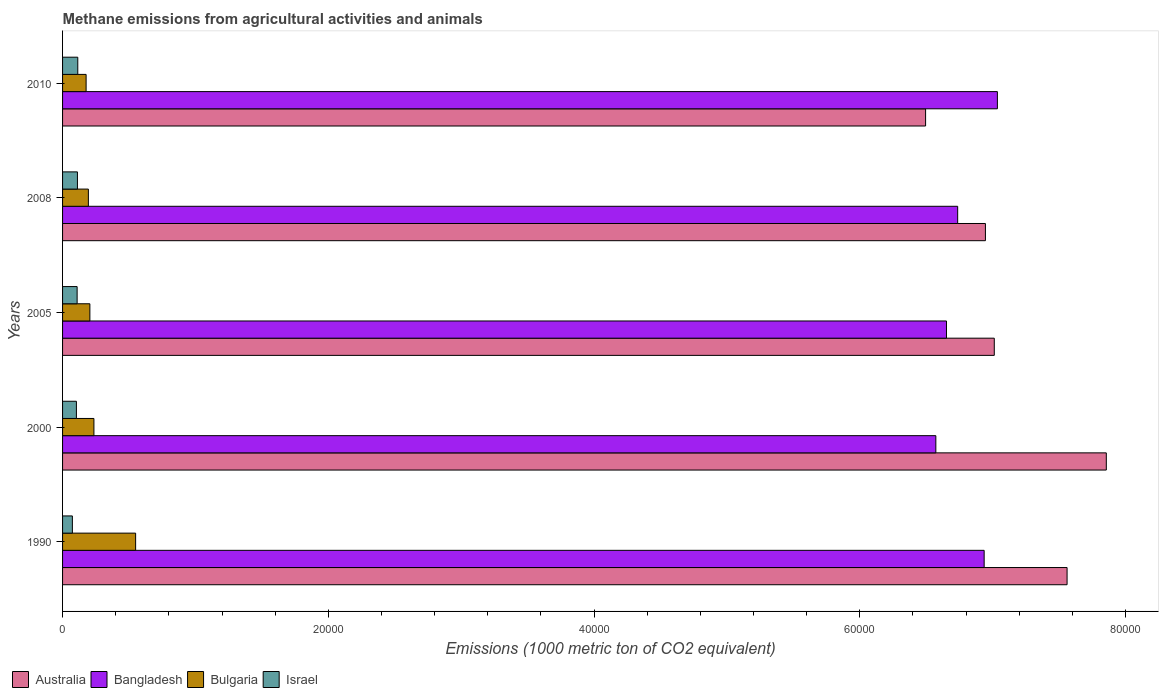Are the number of bars per tick equal to the number of legend labels?
Your answer should be compact. Yes. What is the label of the 3rd group of bars from the top?
Provide a succinct answer. 2005. What is the amount of methane emitted in Bangladesh in 1990?
Your answer should be very brief. 6.94e+04. Across all years, what is the maximum amount of methane emitted in Australia?
Provide a succinct answer. 7.85e+04. Across all years, what is the minimum amount of methane emitted in Israel?
Offer a terse response. 737.7. In which year was the amount of methane emitted in Australia maximum?
Give a very brief answer. 2000. What is the total amount of methane emitted in Bangladesh in the graph?
Offer a terse response. 3.39e+05. What is the difference between the amount of methane emitted in Australia in 1990 and that in 2008?
Keep it short and to the point. 6145.3. What is the difference between the amount of methane emitted in Bulgaria in 2005 and the amount of methane emitted in Australia in 2008?
Your response must be concise. -6.74e+04. What is the average amount of methane emitted in Bangladesh per year?
Offer a terse response. 6.79e+04. In the year 2000, what is the difference between the amount of methane emitted in Australia and amount of methane emitted in Bulgaria?
Offer a very short reply. 7.62e+04. In how many years, is the amount of methane emitted in Bulgaria greater than 72000 1000 metric ton?
Offer a terse response. 0. What is the ratio of the amount of methane emitted in Australia in 2005 to that in 2008?
Your answer should be very brief. 1.01. Is the amount of methane emitted in Israel in 1990 less than that in 2005?
Provide a short and direct response. Yes. What is the difference between the highest and the second highest amount of methane emitted in Bangladesh?
Your response must be concise. 996. What is the difference between the highest and the lowest amount of methane emitted in Israel?
Offer a very short reply. 407.8. In how many years, is the amount of methane emitted in Israel greater than the average amount of methane emitted in Israel taken over all years?
Your answer should be very brief. 4. Is the sum of the amount of methane emitted in Australia in 1990 and 2005 greater than the maximum amount of methane emitted in Israel across all years?
Give a very brief answer. Yes. Is it the case that in every year, the sum of the amount of methane emitted in Bangladesh and amount of methane emitted in Israel is greater than the sum of amount of methane emitted in Bulgaria and amount of methane emitted in Australia?
Your answer should be compact. Yes. What does the 4th bar from the bottom in 1990 represents?
Your response must be concise. Israel. Are all the bars in the graph horizontal?
Make the answer very short. Yes. How many years are there in the graph?
Provide a short and direct response. 5. Are the values on the major ticks of X-axis written in scientific E-notation?
Make the answer very short. No. Does the graph contain any zero values?
Your answer should be compact. No. Does the graph contain grids?
Give a very brief answer. No. What is the title of the graph?
Keep it short and to the point. Methane emissions from agricultural activities and animals. Does "Mauritania" appear as one of the legend labels in the graph?
Make the answer very short. No. What is the label or title of the X-axis?
Your response must be concise. Emissions (1000 metric ton of CO2 equivalent). What is the Emissions (1000 metric ton of CO2 equivalent) in Australia in 1990?
Ensure brevity in your answer.  7.56e+04. What is the Emissions (1000 metric ton of CO2 equivalent) in Bangladesh in 1990?
Offer a very short reply. 6.94e+04. What is the Emissions (1000 metric ton of CO2 equivalent) in Bulgaria in 1990?
Your answer should be compact. 5498.3. What is the Emissions (1000 metric ton of CO2 equivalent) of Israel in 1990?
Provide a short and direct response. 737.7. What is the Emissions (1000 metric ton of CO2 equivalent) in Australia in 2000?
Provide a short and direct response. 7.85e+04. What is the Emissions (1000 metric ton of CO2 equivalent) of Bangladesh in 2000?
Provide a short and direct response. 6.57e+04. What is the Emissions (1000 metric ton of CO2 equivalent) in Bulgaria in 2000?
Provide a short and direct response. 2359.5. What is the Emissions (1000 metric ton of CO2 equivalent) in Israel in 2000?
Ensure brevity in your answer.  1041.6. What is the Emissions (1000 metric ton of CO2 equivalent) of Australia in 2005?
Make the answer very short. 7.01e+04. What is the Emissions (1000 metric ton of CO2 equivalent) in Bangladesh in 2005?
Your answer should be compact. 6.65e+04. What is the Emissions (1000 metric ton of CO2 equivalent) in Bulgaria in 2005?
Ensure brevity in your answer.  2055.2. What is the Emissions (1000 metric ton of CO2 equivalent) in Israel in 2005?
Your answer should be very brief. 1095.9. What is the Emissions (1000 metric ton of CO2 equivalent) in Australia in 2008?
Your response must be concise. 6.95e+04. What is the Emissions (1000 metric ton of CO2 equivalent) in Bangladesh in 2008?
Offer a terse response. 6.74e+04. What is the Emissions (1000 metric ton of CO2 equivalent) in Bulgaria in 2008?
Your response must be concise. 1942.2. What is the Emissions (1000 metric ton of CO2 equivalent) of Israel in 2008?
Offer a very short reply. 1119.7. What is the Emissions (1000 metric ton of CO2 equivalent) in Australia in 2010?
Ensure brevity in your answer.  6.50e+04. What is the Emissions (1000 metric ton of CO2 equivalent) of Bangladesh in 2010?
Offer a very short reply. 7.04e+04. What is the Emissions (1000 metric ton of CO2 equivalent) in Bulgaria in 2010?
Your answer should be compact. 1771.6. What is the Emissions (1000 metric ton of CO2 equivalent) in Israel in 2010?
Ensure brevity in your answer.  1145.5. Across all years, what is the maximum Emissions (1000 metric ton of CO2 equivalent) of Australia?
Your answer should be compact. 7.85e+04. Across all years, what is the maximum Emissions (1000 metric ton of CO2 equivalent) of Bangladesh?
Offer a terse response. 7.04e+04. Across all years, what is the maximum Emissions (1000 metric ton of CO2 equivalent) of Bulgaria?
Give a very brief answer. 5498.3. Across all years, what is the maximum Emissions (1000 metric ton of CO2 equivalent) of Israel?
Your answer should be very brief. 1145.5. Across all years, what is the minimum Emissions (1000 metric ton of CO2 equivalent) in Australia?
Offer a terse response. 6.50e+04. Across all years, what is the minimum Emissions (1000 metric ton of CO2 equivalent) in Bangladesh?
Your response must be concise. 6.57e+04. Across all years, what is the minimum Emissions (1000 metric ton of CO2 equivalent) of Bulgaria?
Offer a terse response. 1771.6. Across all years, what is the minimum Emissions (1000 metric ton of CO2 equivalent) of Israel?
Provide a short and direct response. 737.7. What is the total Emissions (1000 metric ton of CO2 equivalent) in Australia in the graph?
Your answer should be compact. 3.59e+05. What is the total Emissions (1000 metric ton of CO2 equivalent) in Bangladesh in the graph?
Ensure brevity in your answer.  3.39e+05. What is the total Emissions (1000 metric ton of CO2 equivalent) in Bulgaria in the graph?
Offer a terse response. 1.36e+04. What is the total Emissions (1000 metric ton of CO2 equivalent) in Israel in the graph?
Offer a terse response. 5140.4. What is the difference between the Emissions (1000 metric ton of CO2 equivalent) of Australia in 1990 and that in 2000?
Offer a terse response. -2952.5. What is the difference between the Emissions (1000 metric ton of CO2 equivalent) in Bangladesh in 1990 and that in 2000?
Provide a short and direct response. 3636.5. What is the difference between the Emissions (1000 metric ton of CO2 equivalent) of Bulgaria in 1990 and that in 2000?
Give a very brief answer. 3138.8. What is the difference between the Emissions (1000 metric ton of CO2 equivalent) of Israel in 1990 and that in 2000?
Keep it short and to the point. -303.9. What is the difference between the Emissions (1000 metric ton of CO2 equivalent) in Australia in 1990 and that in 2005?
Your response must be concise. 5478.7. What is the difference between the Emissions (1000 metric ton of CO2 equivalent) of Bangladesh in 1990 and that in 2005?
Make the answer very short. 2835.6. What is the difference between the Emissions (1000 metric ton of CO2 equivalent) of Bulgaria in 1990 and that in 2005?
Provide a short and direct response. 3443.1. What is the difference between the Emissions (1000 metric ton of CO2 equivalent) in Israel in 1990 and that in 2005?
Provide a succinct answer. -358.2. What is the difference between the Emissions (1000 metric ton of CO2 equivalent) of Australia in 1990 and that in 2008?
Ensure brevity in your answer.  6145.3. What is the difference between the Emissions (1000 metric ton of CO2 equivalent) of Bangladesh in 1990 and that in 2008?
Ensure brevity in your answer.  1993. What is the difference between the Emissions (1000 metric ton of CO2 equivalent) of Bulgaria in 1990 and that in 2008?
Make the answer very short. 3556.1. What is the difference between the Emissions (1000 metric ton of CO2 equivalent) of Israel in 1990 and that in 2008?
Provide a short and direct response. -382. What is the difference between the Emissions (1000 metric ton of CO2 equivalent) of Australia in 1990 and that in 2010?
Your answer should be compact. 1.06e+04. What is the difference between the Emissions (1000 metric ton of CO2 equivalent) in Bangladesh in 1990 and that in 2010?
Your answer should be very brief. -996. What is the difference between the Emissions (1000 metric ton of CO2 equivalent) in Bulgaria in 1990 and that in 2010?
Your answer should be very brief. 3726.7. What is the difference between the Emissions (1000 metric ton of CO2 equivalent) of Israel in 1990 and that in 2010?
Offer a terse response. -407.8. What is the difference between the Emissions (1000 metric ton of CO2 equivalent) of Australia in 2000 and that in 2005?
Give a very brief answer. 8431.2. What is the difference between the Emissions (1000 metric ton of CO2 equivalent) of Bangladesh in 2000 and that in 2005?
Ensure brevity in your answer.  -800.9. What is the difference between the Emissions (1000 metric ton of CO2 equivalent) of Bulgaria in 2000 and that in 2005?
Your answer should be very brief. 304.3. What is the difference between the Emissions (1000 metric ton of CO2 equivalent) of Israel in 2000 and that in 2005?
Offer a terse response. -54.3. What is the difference between the Emissions (1000 metric ton of CO2 equivalent) of Australia in 2000 and that in 2008?
Keep it short and to the point. 9097.8. What is the difference between the Emissions (1000 metric ton of CO2 equivalent) in Bangladesh in 2000 and that in 2008?
Provide a short and direct response. -1643.5. What is the difference between the Emissions (1000 metric ton of CO2 equivalent) of Bulgaria in 2000 and that in 2008?
Make the answer very short. 417.3. What is the difference between the Emissions (1000 metric ton of CO2 equivalent) in Israel in 2000 and that in 2008?
Provide a short and direct response. -78.1. What is the difference between the Emissions (1000 metric ton of CO2 equivalent) in Australia in 2000 and that in 2010?
Offer a terse response. 1.36e+04. What is the difference between the Emissions (1000 metric ton of CO2 equivalent) of Bangladesh in 2000 and that in 2010?
Keep it short and to the point. -4632.5. What is the difference between the Emissions (1000 metric ton of CO2 equivalent) of Bulgaria in 2000 and that in 2010?
Offer a terse response. 587.9. What is the difference between the Emissions (1000 metric ton of CO2 equivalent) of Israel in 2000 and that in 2010?
Provide a short and direct response. -103.9. What is the difference between the Emissions (1000 metric ton of CO2 equivalent) of Australia in 2005 and that in 2008?
Give a very brief answer. 666.6. What is the difference between the Emissions (1000 metric ton of CO2 equivalent) of Bangladesh in 2005 and that in 2008?
Give a very brief answer. -842.6. What is the difference between the Emissions (1000 metric ton of CO2 equivalent) of Bulgaria in 2005 and that in 2008?
Offer a very short reply. 113. What is the difference between the Emissions (1000 metric ton of CO2 equivalent) of Israel in 2005 and that in 2008?
Offer a terse response. -23.8. What is the difference between the Emissions (1000 metric ton of CO2 equivalent) of Australia in 2005 and that in 2010?
Provide a short and direct response. 5168.4. What is the difference between the Emissions (1000 metric ton of CO2 equivalent) in Bangladesh in 2005 and that in 2010?
Provide a succinct answer. -3831.6. What is the difference between the Emissions (1000 metric ton of CO2 equivalent) of Bulgaria in 2005 and that in 2010?
Provide a succinct answer. 283.6. What is the difference between the Emissions (1000 metric ton of CO2 equivalent) of Israel in 2005 and that in 2010?
Provide a short and direct response. -49.6. What is the difference between the Emissions (1000 metric ton of CO2 equivalent) in Australia in 2008 and that in 2010?
Give a very brief answer. 4501.8. What is the difference between the Emissions (1000 metric ton of CO2 equivalent) of Bangladesh in 2008 and that in 2010?
Make the answer very short. -2989. What is the difference between the Emissions (1000 metric ton of CO2 equivalent) of Bulgaria in 2008 and that in 2010?
Provide a short and direct response. 170.6. What is the difference between the Emissions (1000 metric ton of CO2 equivalent) in Israel in 2008 and that in 2010?
Provide a short and direct response. -25.8. What is the difference between the Emissions (1000 metric ton of CO2 equivalent) in Australia in 1990 and the Emissions (1000 metric ton of CO2 equivalent) in Bangladesh in 2000?
Keep it short and to the point. 9876.4. What is the difference between the Emissions (1000 metric ton of CO2 equivalent) of Australia in 1990 and the Emissions (1000 metric ton of CO2 equivalent) of Bulgaria in 2000?
Offer a very short reply. 7.32e+04. What is the difference between the Emissions (1000 metric ton of CO2 equivalent) in Australia in 1990 and the Emissions (1000 metric ton of CO2 equivalent) in Israel in 2000?
Ensure brevity in your answer.  7.46e+04. What is the difference between the Emissions (1000 metric ton of CO2 equivalent) in Bangladesh in 1990 and the Emissions (1000 metric ton of CO2 equivalent) in Bulgaria in 2000?
Make the answer very short. 6.70e+04. What is the difference between the Emissions (1000 metric ton of CO2 equivalent) in Bangladesh in 1990 and the Emissions (1000 metric ton of CO2 equivalent) in Israel in 2000?
Give a very brief answer. 6.83e+04. What is the difference between the Emissions (1000 metric ton of CO2 equivalent) of Bulgaria in 1990 and the Emissions (1000 metric ton of CO2 equivalent) of Israel in 2000?
Your answer should be compact. 4456.7. What is the difference between the Emissions (1000 metric ton of CO2 equivalent) of Australia in 1990 and the Emissions (1000 metric ton of CO2 equivalent) of Bangladesh in 2005?
Your response must be concise. 9075.5. What is the difference between the Emissions (1000 metric ton of CO2 equivalent) of Australia in 1990 and the Emissions (1000 metric ton of CO2 equivalent) of Bulgaria in 2005?
Your answer should be very brief. 7.35e+04. What is the difference between the Emissions (1000 metric ton of CO2 equivalent) in Australia in 1990 and the Emissions (1000 metric ton of CO2 equivalent) in Israel in 2005?
Keep it short and to the point. 7.45e+04. What is the difference between the Emissions (1000 metric ton of CO2 equivalent) in Bangladesh in 1990 and the Emissions (1000 metric ton of CO2 equivalent) in Bulgaria in 2005?
Offer a very short reply. 6.73e+04. What is the difference between the Emissions (1000 metric ton of CO2 equivalent) of Bangladesh in 1990 and the Emissions (1000 metric ton of CO2 equivalent) of Israel in 2005?
Your answer should be compact. 6.83e+04. What is the difference between the Emissions (1000 metric ton of CO2 equivalent) of Bulgaria in 1990 and the Emissions (1000 metric ton of CO2 equivalent) of Israel in 2005?
Offer a very short reply. 4402.4. What is the difference between the Emissions (1000 metric ton of CO2 equivalent) of Australia in 1990 and the Emissions (1000 metric ton of CO2 equivalent) of Bangladesh in 2008?
Keep it short and to the point. 8232.9. What is the difference between the Emissions (1000 metric ton of CO2 equivalent) in Australia in 1990 and the Emissions (1000 metric ton of CO2 equivalent) in Bulgaria in 2008?
Offer a terse response. 7.37e+04. What is the difference between the Emissions (1000 metric ton of CO2 equivalent) of Australia in 1990 and the Emissions (1000 metric ton of CO2 equivalent) of Israel in 2008?
Offer a very short reply. 7.45e+04. What is the difference between the Emissions (1000 metric ton of CO2 equivalent) in Bangladesh in 1990 and the Emissions (1000 metric ton of CO2 equivalent) in Bulgaria in 2008?
Make the answer very short. 6.74e+04. What is the difference between the Emissions (1000 metric ton of CO2 equivalent) in Bangladesh in 1990 and the Emissions (1000 metric ton of CO2 equivalent) in Israel in 2008?
Make the answer very short. 6.82e+04. What is the difference between the Emissions (1000 metric ton of CO2 equivalent) of Bulgaria in 1990 and the Emissions (1000 metric ton of CO2 equivalent) of Israel in 2008?
Offer a very short reply. 4378.6. What is the difference between the Emissions (1000 metric ton of CO2 equivalent) in Australia in 1990 and the Emissions (1000 metric ton of CO2 equivalent) in Bangladesh in 2010?
Your answer should be very brief. 5243.9. What is the difference between the Emissions (1000 metric ton of CO2 equivalent) of Australia in 1990 and the Emissions (1000 metric ton of CO2 equivalent) of Bulgaria in 2010?
Provide a short and direct response. 7.38e+04. What is the difference between the Emissions (1000 metric ton of CO2 equivalent) in Australia in 1990 and the Emissions (1000 metric ton of CO2 equivalent) in Israel in 2010?
Your answer should be very brief. 7.45e+04. What is the difference between the Emissions (1000 metric ton of CO2 equivalent) in Bangladesh in 1990 and the Emissions (1000 metric ton of CO2 equivalent) in Bulgaria in 2010?
Your response must be concise. 6.76e+04. What is the difference between the Emissions (1000 metric ton of CO2 equivalent) in Bangladesh in 1990 and the Emissions (1000 metric ton of CO2 equivalent) in Israel in 2010?
Give a very brief answer. 6.82e+04. What is the difference between the Emissions (1000 metric ton of CO2 equivalent) of Bulgaria in 1990 and the Emissions (1000 metric ton of CO2 equivalent) of Israel in 2010?
Offer a very short reply. 4352.8. What is the difference between the Emissions (1000 metric ton of CO2 equivalent) of Australia in 2000 and the Emissions (1000 metric ton of CO2 equivalent) of Bangladesh in 2005?
Provide a short and direct response. 1.20e+04. What is the difference between the Emissions (1000 metric ton of CO2 equivalent) in Australia in 2000 and the Emissions (1000 metric ton of CO2 equivalent) in Bulgaria in 2005?
Your answer should be very brief. 7.65e+04. What is the difference between the Emissions (1000 metric ton of CO2 equivalent) of Australia in 2000 and the Emissions (1000 metric ton of CO2 equivalent) of Israel in 2005?
Provide a succinct answer. 7.75e+04. What is the difference between the Emissions (1000 metric ton of CO2 equivalent) in Bangladesh in 2000 and the Emissions (1000 metric ton of CO2 equivalent) in Bulgaria in 2005?
Offer a terse response. 6.37e+04. What is the difference between the Emissions (1000 metric ton of CO2 equivalent) in Bangladesh in 2000 and the Emissions (1000 metric ton of CO2 equivalent) in Israel in 2005?
Ensure brevity in your answer.  6.46e+04. What is the difference between the Emissions (1000 metric ton of CO2 equivalent) of Bulgaria in 2000 and the Emissions (1000 metric ton of CO2 equivalent) of Israel in 2005?
Keep it short and to the point. 1263.6. What is the difference between the Emissions (1000 metric ton of CO2 equivalent) in Australia in 2000 and the Emissions (1000 metric ton of CO2 equivalent) in Bangladesh in 2008?
Keep it short and to the point. 1.12e+04. What is the difference between the Emissions (1000 metric ton of CO2 equivalent) in Australia in 2000 and the Emissions (1000 metric ton of CO2 equivalent) in Bulgaria in 2008?
Ensure brevity in your answer.  7.66e+04. What is the difference between the Emissions (1000 metric ton of CO2 equivalent) in Australia in 2000 and the Emissions (1000 metric ton of CO2 equivalent) in Israel in 2008?
Make the answer very short. 7.74e+04. What is the difference between the Emissions (1000 metric ton of CO2 equivalent) in Bangladesh in 2000 and the Emissions (1000 metric ton of CO2 equivalent) in Bulgaria in 2008?
Ensure brevity in your answer.  6.38e+04. What is the difference between the Emissions (1000 metric ton of CO2 equivalent) of Bangladesh in 2000 and the Emissions (1000 metric ton of CO2 equivalent) of Israel in 2008?
Provide a short and direct response. 6.46e+04. What is the difference between the Emissions (1000 metric ton of CO2 equivalent) in Bulgaria in 2000 and the Emissions (1000 metric ton of CO2 equivalent) in Israel in 2008?
Offer a terse response. 1239.8. What is the difference between the Emissions (1000 metric ton of CO2 equivalent) of Australia in 2000 and the Emissions (1000 metric ton of CO2 equivalent) of Bangladesh in 2010?
Your answer should be compact. 8196.4. What is the difference between the Emissions (1000 metric ton of CO2 equivalent) of Australia in 2000 and the Emissions (1000 metric ton of CO2 equivalent) of Bulgaria in 2010?
Ensure brevity in your answer.  7.68e+04. What is the difference between the Emissions (1000 metric ton of CO2 equivalent) of Australia in 2000 and the Emissions (1000 metric ton of CO2 equivalent) of Israel in 2010?
Provide a short and direct response. 7.74e+04. What is the difference between the Emissions (1000 metric ton of CO2 equivalent) of Bangladesh in 2000 and the Emissions (1000 metric ton of CO2 equivalent) of Bulgaria in 2010?
Make the answer very short. 6.39e+04. What is the difference between the Emissions (1000 metric ton of CO2 equivalent) in Bangladesh in 2000 and the Emissions (1000 metric ton of CO2 equivalent) in Israel in 2010?
Keep it short and to the point. 6.46e+04. What is the difference between the Emissions (1000 metric ton of CO2 equivalent) of Bulgaria in 2000 and the Emissions (1000 metric ton of CO2 equivalent) of Israel in 2010?
Offer a very short reply. 1214. What is the difference between the Emissions (1000 metric ton of CO2 equivalent) of Australia in 2005 and the Emissions (1000 metric ton of CO2 equivalent) of Bangladesh in 2008?
Your answer should be compact. 2754.2. What is the difference between the Emissions (1000 metric ton of CO2 equivalent) of Australia in 2005 and the Emissions (1000 metric ton of CO2 equivalent) of Bulgaria in 2008?
Provide a succinct answer. 6.82e+04. What is the difference between the Emissions (1000 metric ton of CO2 equivalent) of Australia in 2005 and the Emissions (1000 metric ton of CO2 equivalent) of Israel in 2008?
Make the answer very short. 6.90e+04. What is the difference between the Emissions (1000 metric ton of CO2 equivalent) in Bangladesh in 2005 and the Emissions (1000 metric ton of CO2 equivalent) in Bulgaria in 2008?
Offer a very short reply. 6.46e+04. What is the difference between the Emissions (1000 metric ton of CO2 equivalent) in Bangladesh in 2005 and the Emissions (1000 metric ton of CO2 equivalent) in Israel in 2008?
Your answer should be very brief. 6.54e+04. What is the difference between the Emissions (1000 metric ton of CO2 equivalent) in Bulgaria in 2005 and the Emissions (1000 metric ton of CO2 equivalent) in Israel in 2008?
Your response must be concise. 935.5. What is the difference between the Emissions (1000 metric ton of CO2 equivalent) of Australia in 2005 and the Emissions (1000 metric ton of CO2 equivalent) of Bangladesh in 2010?
Make the answer very short. -234.8. What is the difference between the Emissions (1000 metric ton of CO2 equivalent) of Australia in 2005 and the Emissions (1000 metric ton of CO2 equivalent) of Bulgaria in 2010?
Provide a succinct answer. 6.83e+04. What is the difference between the Emissions (1000 metric ton of CO2 equivalent) of Australia in 2005 and the Emissions (1000 metric ton of CO2 equivalent) of Israel in 2010?
Ensure brevity in your answer.  6.90e+04. What is the difference between the Emissions (1000 metric ton of CO2 equivalent) in Bangladesh in 2005 and the Emissions (1000 metric ton of CO2 equivalent) in Bulgaria in 2010?
Provide a short and direct response. 6.48e+04. What is the difference between the Emissions (1000 metric ton of CO2 equivalent) in Bangladesh in 2005 and the Emissions (1000 metric ton of CO2 equivalent) in Israel in 2010?
Provide a short and direct response. 6.54e+04. What is the difference between the Emissions (1000 metric ton of CO2 equivalent) in Bulgaria in 2005 and the Emissions (1000 metric ton of CO2 equivalent) in Israel in 2010?
Give a very brief answer. 909.7. What is the difference between the Emissions (1000 metric ton of CO2 equivalent) of Australia in 2008 and the Emissions (1000 metric ton of CO2 equivalent) of Bangladesh in 2010?
Provide a succinct answer. -901.4. What is the difference between the Emissions (1000 metric ton of CO2 equivalent) of Australia in 2008 and the Emissions (1000 metric ton of CO2 equivalent) of Bulgaria in 2010?
Your response must be concise. 6.77e+04. What is the difference between the Emissions (1000 metric ton of CO2 equivalent) of Australia in 2008 and the Emissions (1000 metric ton of CO2 equivalent) of Israel in 2010?
Your answer should be compact. 6.83e+04. What is the difference between the Emissions (1000 metric ton of CO2 equivalent) of Bangladesh in 2008 and the Emissions (1000 metric ton of CO2 equivalent) of Bulgaria in 2010?
Your answer should be very brief. 6.56e+04. What is the difference between the Emissions (1000 metric ton of CO2 equivalent) in Bangladesh in 2008 and the Emissions (1000 metric ton of CO2 equivalent) in Israel in 2010?
Your answer should be very brief. 6.62e+04. What is the difference between the Emissions (1000 metric ton of CO2 equivalent) of Bulgaria in 2008 and the Emissions (1000 metric ton of CO2 equivalent) of Israel in 2010?
Your answer should be very brief. 796.7. What is the average Emissions (1000 metric ton of CO2 equivalent) in Australia per year?
Provide a succinct answer. 7.17e+04. What is the average Emissions (1000 metric ton of CO2 equivalent) in Bangladesh per year?
Make the answer very short. 6.79e+04. What is the average Emissions (1000 metric ton of CO2 equivalent) of Bulgaria per year?
Give a very brief answer. 2725.36. What is the average Emissions (1000 metric ton of CO2 equivalent) in Israel per year?
Your response must be concise. 1028.08. In the year 1990, what is the difference between the Emissions (1000 metric ton of CO2 equivalent) of Australia and Emissions (1000 metric ton of CO2 equivalent) of Bangladesh?
Provide a succinct answer. 6239.9. In the year 1990, what is the difference between the Emissions (1000 metric ton of CO2 equivalent) in Australia and Emissions (1000 metric ton of CO2 equivalent) in Bulgaria?
Provide a short and direct response. 7.01e+04. In the year 1990, what is the difference between the Emissions (1000 metric ton of CO2 equivalent) in Australia and Emissions (1000 metric ton of CO2 equivalent) in Israel?
Give a very brief answer. 7.49e+04. In the year 1990, what is the difference between the Emissions (1000 metric ton of CO2 equivalent) in Bangladesh and Emissions (1000 metric ton of CO2 equivalent) in Bulgaria?
Give a very brief answer. 6.39e+04. In the year 1990, what is the difference between the Emissions (1000 metric ton of CO2 equivalent) of Bangladesh and Emissions (1000 metric ton of CO2 equivalent) of Israel?
Make the answer very short. 6.86e+04. In the year 1990, what is the difference between the Emissions (1000 metric ton of CO2 equivalent) in Bulgaria and Emissions (1000 metric ton of CO2 equivalent) in Israel?
Provide a short and direct response. 4760.6. In the year 2000, what is the difference between the Emissions (1000 metric ton of CO2 equivalent) in Australia and Emissions (1000 metric ton of CO2 equivalent) in Bangladesh?
Ensure brevity in your answer.  1.28e+04. In the year 2000, what is the difference between the Emissions (1000 metric ton of CO2 equivalent) of Australia and Emissions (1000 metric ton of CO2 equivalent) of Bulgaria?
Make the answer very short. 7.62e+04. In the year 2000, what is the difference between the Emissions (1000 metric ton of CO2 equivalent) in Australia and Emissions (1000 metric ton of CO2 equivalent) in Israel?
Ensure brevity in your answer.  7.75e+04. In the year 2000, what is the difference between the Emissions (1000 metric ton of CO2 equivalent) of Bangladesh and Emissions (1000 metric ton of CO2 equivalent) of Bulgaria?
Offer a terse response. 6.34e+04. In the year 2000, what is the difference between the Emissions (1000 metric ton of CO2 equivalent) in Bangladesh and Emissions (1000 metric ton of CO2 equivalent) in Israel?
Keep it short and to the point. 6.47e+04. In the year 2000, what is the difference between the Emissions (1000 metric ton of CO2 equivalent) of Bulgaria and Emissions (1000 metric ton of CO2 equivalent) of Israel?
Keep it short and to the point. 1317.9. In the year 2005, what is the difference between the Emissions (1000 metric ton of CO2 equivalent) in Australia and Emissions (1000 metric ton of CO2 equivalent) in Bangladesh?
Make the answer very short. 3596.8. In the year 2005, what is the difference between the Emissions (1000 metric ton of CO2 equivalent) of Australia and Emissions (1000 metric ton of CO2 equivalent) of Bulgaria?
Keep it short and to the point. 6.81e+04. In the year 2005, what is the difference between the Emissions (1000 metric ton of CO2 equivalent) of Australia and Emissions (1000 metric ton of CO2 equivalent) of Israel?
Your answer should be very brief. 6.90e+04. In the year 2005, what is the difference between the Emissions (1000 metric ton of CO2 equivalent) of Bangladesh and Emissions (1000 metric ton of CO2 equivalent) of Bulgaria?
Provide a succinct answer. 6.45e+04. In the year 2005, what is the difference between the Emissions (1000 metric ton of CO2 equivalent) of Bangladesh and Emissions (1000 metric ton of CO2 equivalent) of Israel?
Give a very brief answer. 6.54e+04. In the year 2005, what is the difference between the Emissions (1000 metric ton of CO2 equivalent) of Bulgaria and Emissions (1000 metric ton of CO2 equivalent) of Israel?
Make the answer very short. 959.3. In the year 2008, what is the difference between the Emissions (1000 metric ton of CO2 equivalent) in Australia and Emissions (1000 metric ton of CO2 equivalent) in Bangladesh?
Keep it short and to the point. 2087.6. In the year 2008, what is the difference between the Emissions (1000 metric ton of CO2 equivalent) of Australia and Emissions (1000 metric ton of CO2 equivalent) of Bulgaria?
Give a very brief answer. 6.75e+04. In the year 2008, what is the difference between the Emissions (1000 metric ton of CO2 equivalent) of Australia and Emissions (1000 metric ton of CO2 equivalent) of Israel?
Offer a terse response. 6.83e+04. In the year 2008, what is the difference between the Emissions (1000 metric ton of CO2 equivalent) in Bangladesh and Emissions (1000 metric ton of CO2 equivalent) in Bulgaria?
Give a very brief answer. 6.54e+04. In the year 2008, what is the difference between the Emissions (1000 metric ton of CO2 equivalent) in Bangladesh and Emissions (1000 metric ton of CO2 equivalent) in Israel?
Offer a very short reply. 6.62e+04. In the year 2008, what is the difference between the Emissions (1000 metric ton of CO2 equivalent) of Bulgaria and Emissions (1000 metric ton of CO2 equivalent) of Israel?
Give a very brief answer. 822.5. In the year 2010, what is the difference between the Emissions (1000 metric ton of CO2 equivalent) of Australia and Emissions (1000 metric ton of CO2 equivalent) of Bangladesh?
Give a very brief answer. -5403.2. In the year 2010, what is the difference between the Emissions (1000 metric ton of CO2 equivalent) in Australia and Emissions (1000 metric ton of CO2 equivalent) in Bulgaria?
Provide a short and direct response. 6.32e+04. In the year 2010, what is the difference between the Emissions (1000 metric ton of CO2 equivalent) in Australia and Emissions (1000 metric ton of CO2 equivalent) in Israel?
Offer a terse response. 6.38e+04. In the year 2010, what is the difference between the Emissions (1000 metric ton of CO2 equivalent) in Bangladesh and Emissions (1000 metric ton of CO2 equivalent) in Bulgaria?
Provide a succinct answer. 6.86e+04. In the year 2010, what is the difference between the Emissions (1000 metric ton of CO2 equivalent) of Bangladesh and Emissions (1000 metric ton of CO2 equivalent) of Israel?
Your answer should be very brief. 6.92e+04. In the year 2010, what is the difference between the Emissions (1000 metric ton of CO2 equivalent) of Bulgaria and Emissions (1000 metric ton of CO2 equivalent) of Israel?
Give a very brief answer. 626.1. What is the ratio of the Emissions (1000 metric ton of CO2 equivalent) of Australia in 1990 to that in 2000?
Offer a terse response. 0.96. What is the ratio of the Emissions (1000 metric ton of CO2 equivalent) of Bangladesh in 1990 to that in 2000?
Your answer should be compact. 1.06. What is the ratio of the Emissions (1000 metric ton of CO2 equivalent) in Bulgaria in 1990 to that in 2000?
Ensure brevity in your answer.  2.33. What is the ratio of the Emissions (1000 metric ton of CO2 equivalent) of Israel in 1990 to that in 2000?
Your answer should be compact. 0.71. What is the ratio of the Emissions (1000 metric ton of CO2 equivalent) in Australia in 1990 to that in 2005?
Your response must be concise. 1.08. What is the ratio of the Emissions (1000 metric ton of CO2 equivalent) in Bangladesh in 1990 to that in 2005?
Give a very brief answer. 1.04. What is the ratio of the Emissions (1000 metric ton of CO2 equivalent) of Bulgaria in 1990 to that in 2005?
Offer a terse response. 2.68. What is the ratio of the Emissions (1000 metric ton of CO2 equivalent) of Israel in 1990 to that in 2005?
Offer a very short reply. 0.67. What is the ratio of the Emissions (1000 metric ton of CO2 equivalent) in Australia in 1990 to that in 2008?
Provide a succinct answer. 1.09. What is the ratio of the Emissions (1000 metric ton of CO2 equivalent) in Bangladesh in 1990 to that in 2008?
Give a very brief answer. 1.03. What is the ratio of the Emissions (1000 metric ton of CO2 equivalent) of Bulgaria in 1990 to that in 2008?
Provide a succinct answer. 2.83. What is the ratio of the Emissions (1000 metric ton of CO2 equivalent) in Israel in 1990 to that in 2008?
Your response must be concise. 0.66. What is the ratio of the Emissions (1000 metric ton of CO2 equivalent) of Australia in 1990 to that in 2010?
Offer a very short reply. 1.16. What is the ratio of the Emissions (1000 metric ton of CO2 equivalent) of Bangladesh in 1990 to that in 2010?
Ensure brevity in your answer.  0.99. What is the ratio of the Emissions (1000 metric ton of CO2 equivalent) in Bulgaria in 1990 to that in 2010?
Ensure brevity in your answer.  3.1. What is the ratio of the Emissions (1000 metric ton of CO2 equivalent) of Israel in 1990 to that in 2010?
Offer a terse response. 0.64. What is the ratio of the Emissions (1000 metric ton of CO2 equivalent) in Australia in 2000 to that in 2005?
Keep it short and to the point. 1.12. What is the ratio of the Emissions (1000 metric ton of CO2 equivalent) in Bulgaria in 2000 to that in 2005?
Provide a succinct answer. 1.15. What is the ratio of the Emissions (1000 metric ton of CO2 equivalent) in Israel in 2000 to that in 2005?
Make the answer very short. 0.95. What is the ratio of the Emissions (1000 metric ton of CO2 equivalent) in Australia in 2000 to that in 2008?
Your response must be concise. 1.13. What is the ratio of the Emissions (1000 metric ton of CO2 equivalent) of Bangladesh in 2000 to that in 2008?
Provide a succinct answer. 0.98. What is the ratio of the Emissions (1000 metric ton of CO2 equivalent) in Bulgaria in 2000 to that in 2008?
Offer a terse response. 1.21. What is the ratio of the Emissions (1000 metric ton of CO2 equivalent) of Israel in 2000 to that in 2008?
Give a very brief answer. 0.93. What is the ratio of the Emissions (1000 metric ton of CO2 equivalent) of Australia in 2000 to that in 2010?
Keep it short and to the point. 1.21. What is the ratio of the Emissions (1000 metric ton of CO2 equivalent) of Bangladesh in 2000 to that in 2010?
Offer a very short reply. 0.93. What is the ratio of the Emissions (1000 metric ton of CO2 equivalent) of Bulgaria in 2000 to that in 2010?
Provide a short and direct response. 1.33. What is the ratio of the Emissions (1000 metric ton of CO2 equivalent) of Israel in 2000 to that in 2010?
Provide a short and direct response. 0.91. What is the ratio of the Emissions (1000 metric ton of CO2 equivalent) of Australia in 2005 to that in 2008?
Offer a very short reply. 1.01. What is the ratio of the Emissions (1000 metric ton of CO2 equivalent) of Bangladesh in 2005 to that in 2008?
Provide a succinct answer. 0.99. What is the ratio of the Emissions (1000 metric ton of CO2 equivalent) in Bulgaria in 2005 to that in 2008?
Keep it short and to the point. 1.06. What is the ratio of the Emissions (1000 metric ton of CO2 equivalent) of Israel in 2005 to that in 2008?
Keep it short and to the point. 0.98. What is the ratio of the Emissions (1000 metric ton of CO2 equivalent) in Australia in 2005 to that in 2010?
Provide a succinct answer. 1.08. What is the ratio of the Emissions (1000 metric ton of CO2 equivalent) of Bangladesh in 2005 to that in 2010?
Your answer should be very brief. 0.95. What is the ratio of the Emissions (1000 metric ton of CO2 equivalent) in Bulgaria in 2005 to that in 2010?
Offer a very short reply. 1.16. What is the ratio of the Emissions (1000 metric ton of CO2 equivalent) in Israel in 2005 to that in 2010?
Ensure brevity in your answer.  0.96. What is the ratio of the Emissions (1000 metric ton of CO2 equivalent) of Australia in 2008 to that in 2010?
Offer a terse response. 1.07. What is the ratio of the Emissions (1000 metric ton of CO2 equivalent) of Bangladesh in 2008 to that in 2010?
Keep it short and to the point. 0.96. What is the ratio of the Emissions (1000 metric ton of CO2 equivalent) of Bulgaria in 2008 to that in 2010?
Your answer should be very brief. 1.1. What is the ratio of the Emissions (1000 metric ton of CO2 equivalent) in Israel in 2008 to that in 2010?
Your response must be concise. 0.98. What is the difference between the highest and the second highest Emissions (1000 metric ton of CO2 equivalent) in Australia?
Offer a very short reply. 2952.5. What is the difference between the highest and the second highest Emissions (1000 metric ton of CO2 equivalent) in Bangladesh?
Your answer should be compact. 996. What is the difference between the highest and the second highest Emissions (1000 metric ton of CO2 equivalent) of Bulgaria?
Offer a very short reply. 3138.8. What is the difference between the highest and the second highest Emissions (1000 metric ton of CO2 equivalent) in Israel?
Provide a short and direct response. 25.8. What is the difference between the highest and the lowest Emissions (1000 metric ton of CO2 equivalent) in Australia?
Offer a very short reply. 1.36e+04. What is the difference between the highest and the lowest Emissions (1000 metric ton of CO2 equivalent) of Bangladesh?
Ensure brevity in your answer.  4632.5. What is the difference between the highest and the lowest Emissions (1000 metric ton of CO2 equivalent) in Bulgaria?
Your response must be concise. 3726.7. What is the difference between the highest and the lowest Emissions (1000 metric ton of CO2 equivalent) in Israel?
Your response must be concise. 407.8. 